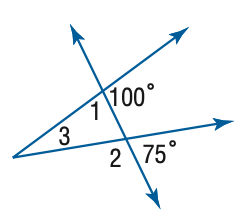Answer the mathemtical geometry problem and directly provide the correct option letter.
Question: Find the measure of \angle 3 in the figure.
Choices: A: 10 B: 15 C: 20 D: 25 D 